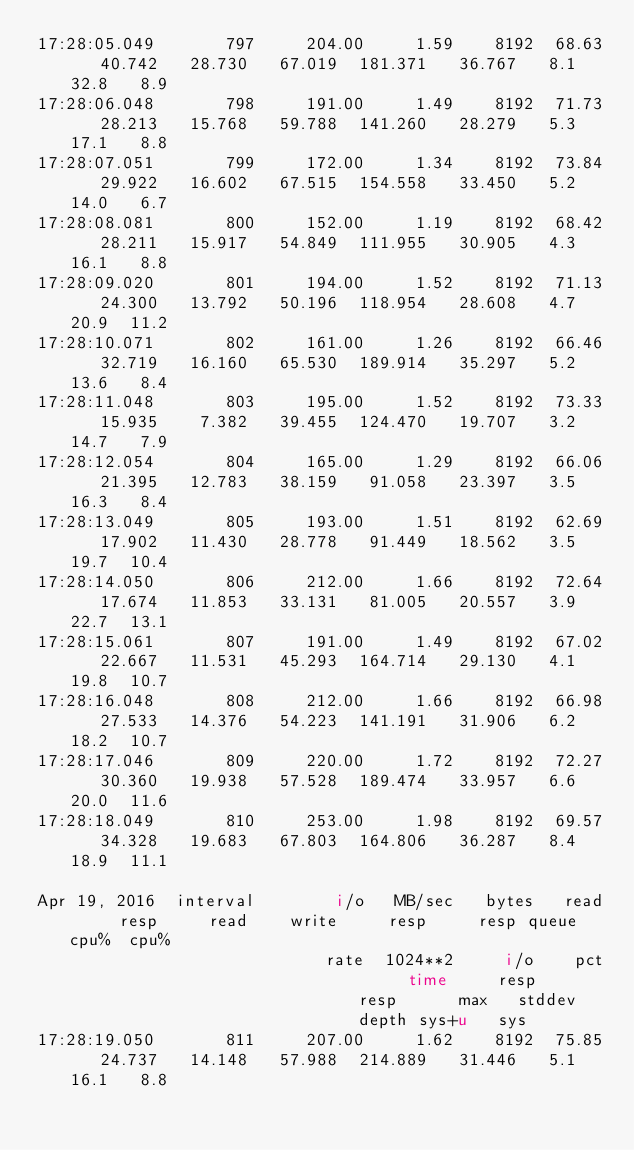<code> <loc_0><loc_0><loc_500><loc_500><_HTML_>17:28:05.049       797     204.00     1.59    8192  68.63   40.742   28.730   67.019  181.371   36.767   8.1  32.8   8.9
17:28:06.048       798     191.00     1.49    8192  71.73   28.213   15.768   59.788  141.260   28.279   5.3  17.1   8.8
17:28:07.051       799     172.00     1.34    8192  73.84   29.922   16.602   67.515  154.558   33.450   5.2  14.0   6.7
17:28:08.081       800     152.00     1.19    8192  68.42   28.211   15.917   54.849  111.955   30.905   4.3  16.1   8.8
17:28:09.020       801     194.00     1.52    8192  71.13   24.300   13.792   50.196  118.954   28.608   4.7  20.9  11.2
17:28:10.071       802     161.00     1.26    8192  66.46   32.719   16.160   65.530  189.914   35.297   5.2  13.6   8.4
17:28:11.048       803     195.00     1.52    8192  73.33   15.935    7.382   39.455  124.470   19.707   3.2  14.7   7.9
17:28:12.054       804     165.00     1.29    8192  66.06   21.395   12.783   38.159   91.058   23.397   3.5  16.3   8.4
17:28:13.049       805     193.00     1.51    8192  62.69   17.902   11.430   28.778   91.449   18.562   3.5  19.7  10.4
17:28:14.050       806     212.00     1.66    8192  72.64   17.674   11.853   33.131   81.005   20.557   3.9  22.7  13.1
17:28:15.061       807     191.00     1.49    8192  67.02   22.667   11.531   45.293  164.714   29.130   4.1  19.8  10.7
17:28:16.048       808     212.00     1.66    8192  66.98   27.533   14.376   54.223  141.191   31.906   6.2  18.2  10.7
17:28:17.046       809     220.00     1.72    8192  72.27   30.360   19.938   57.528  189.474   33.957   6.6  20.0  11.6
17:28:18.049       810     253.00     1.98    8192  69.57   34.328   19.683   67.803  164.806   36.287   8.4  18.9  11.1

Apr 19, 2016  interval        i/o   MB/sec   bytes   read     resp     read    write     resp     resp queue  cpu%  cpu%
                             rate  1024**2     i/o    pct     time     resp     resp      max   stddev depth sys+u   sys
17:28:19.050       811     207.00     1.62    8192  75.85   24.737   14.148   57.988  214.889   31.446   5.1  16.1   8.8</code> 